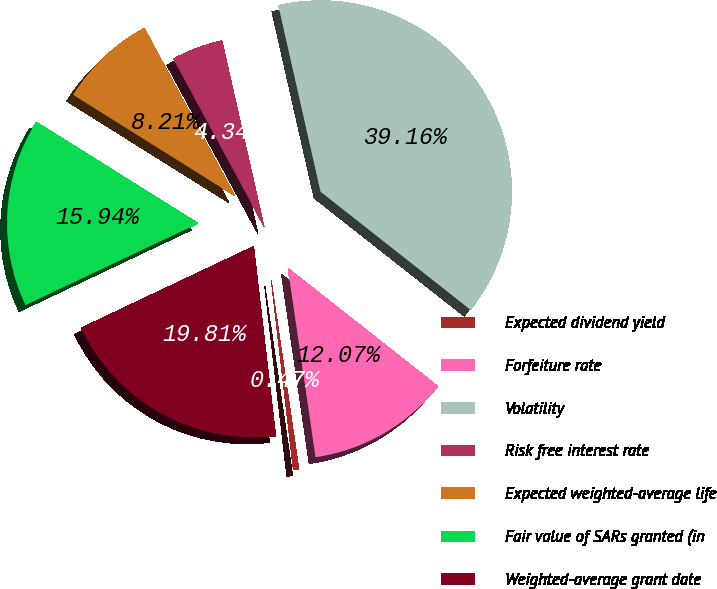Convert chart to OTSL. <chart><loc_0><loc_0><loc_500><loc_500><pie_chart><fcel>Expected dividend yield<fcel>Forfeiture rate<fcel>Volatility<fcel>Risk free interest rate<fcel>Expected weighted-average life<fcel>Fair value of SARs granted (in<fcel>Weighted-average grant date<nl><fcel>0.47%<fcel>12.07%<fcel>39.16%<fcel>4.34%<fcel>8.21%<fcel>15.94%<fcel>19.81%<nl></chart> 